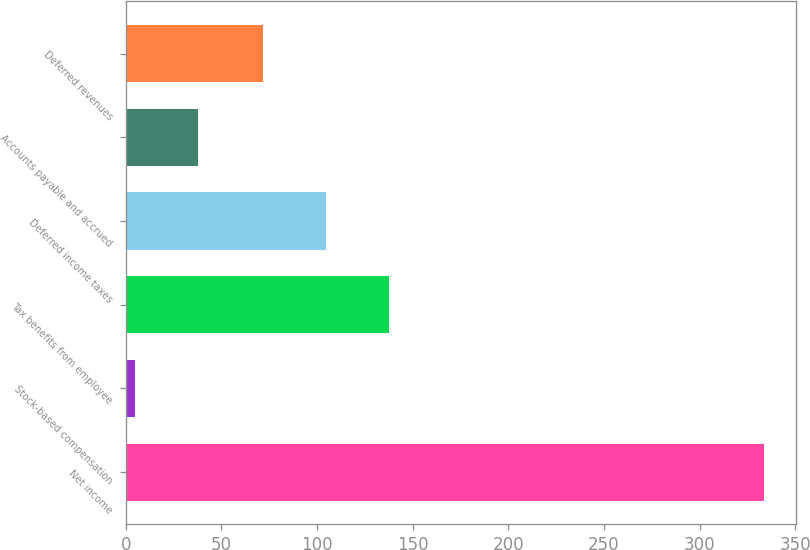Convert chart to OTSL. <chart><loc_0><loc_0><loc_500><loc_500><bar_chart><fcel>Net income<fcel>Stock-based compensation<fcel>Tax benefits from employee<fcel>Deferred income taxes<fcel>Accounts payable and accrued<fcel>Deferred revenues<nl><fcel>333.6<fcel>4.6<fcel>137.5<fcel>104.6<fcel>37.5<fcel>71.7<nl></chart> 